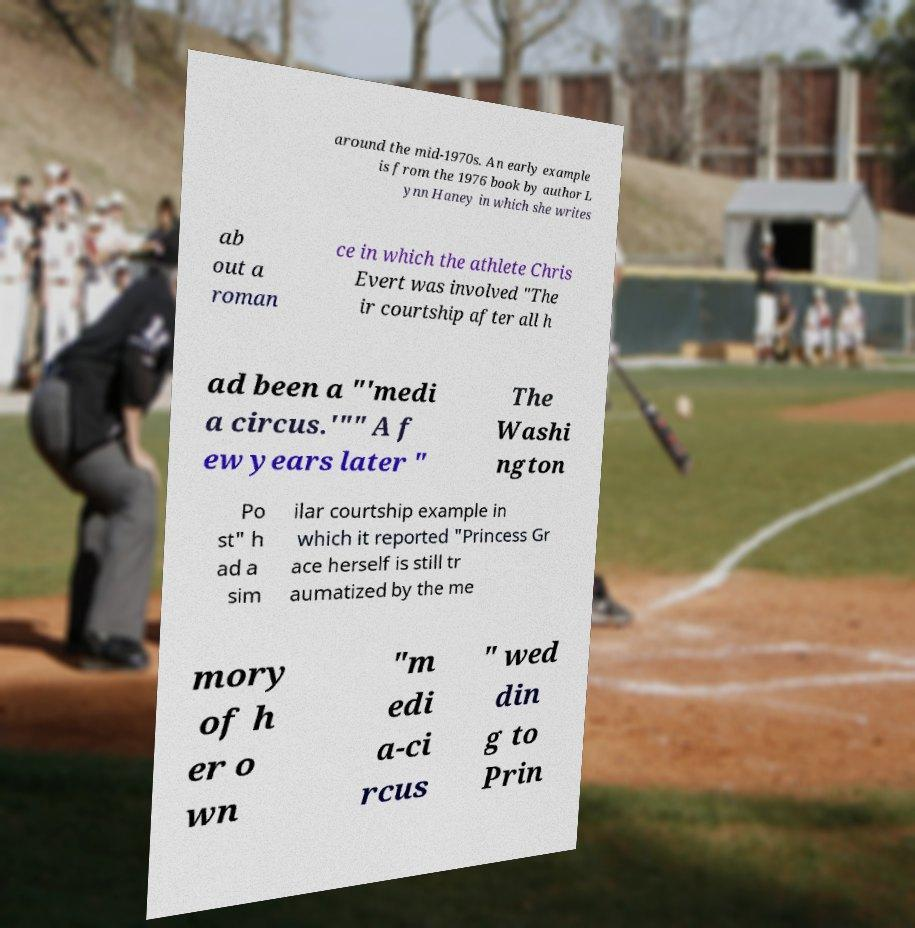For documentation purposes, I need the text within this image transcribed. Could you provide that? around the mid-1970s. An early example is from the 1976 book by author L ynn Haney in which she writes ab out a roman ce in which the athlete Chris Evert was involved "The ir courtship after all h ad been a "'medi a circus.'"" A f ew years later " The Washi ngton Po st" h ad a sim ilar courtship example in which it reported "Princess Gr ace herself is still tr aumatized by the me mory of h er o wn "m edi a-ci rcus " wed din g to Prin 